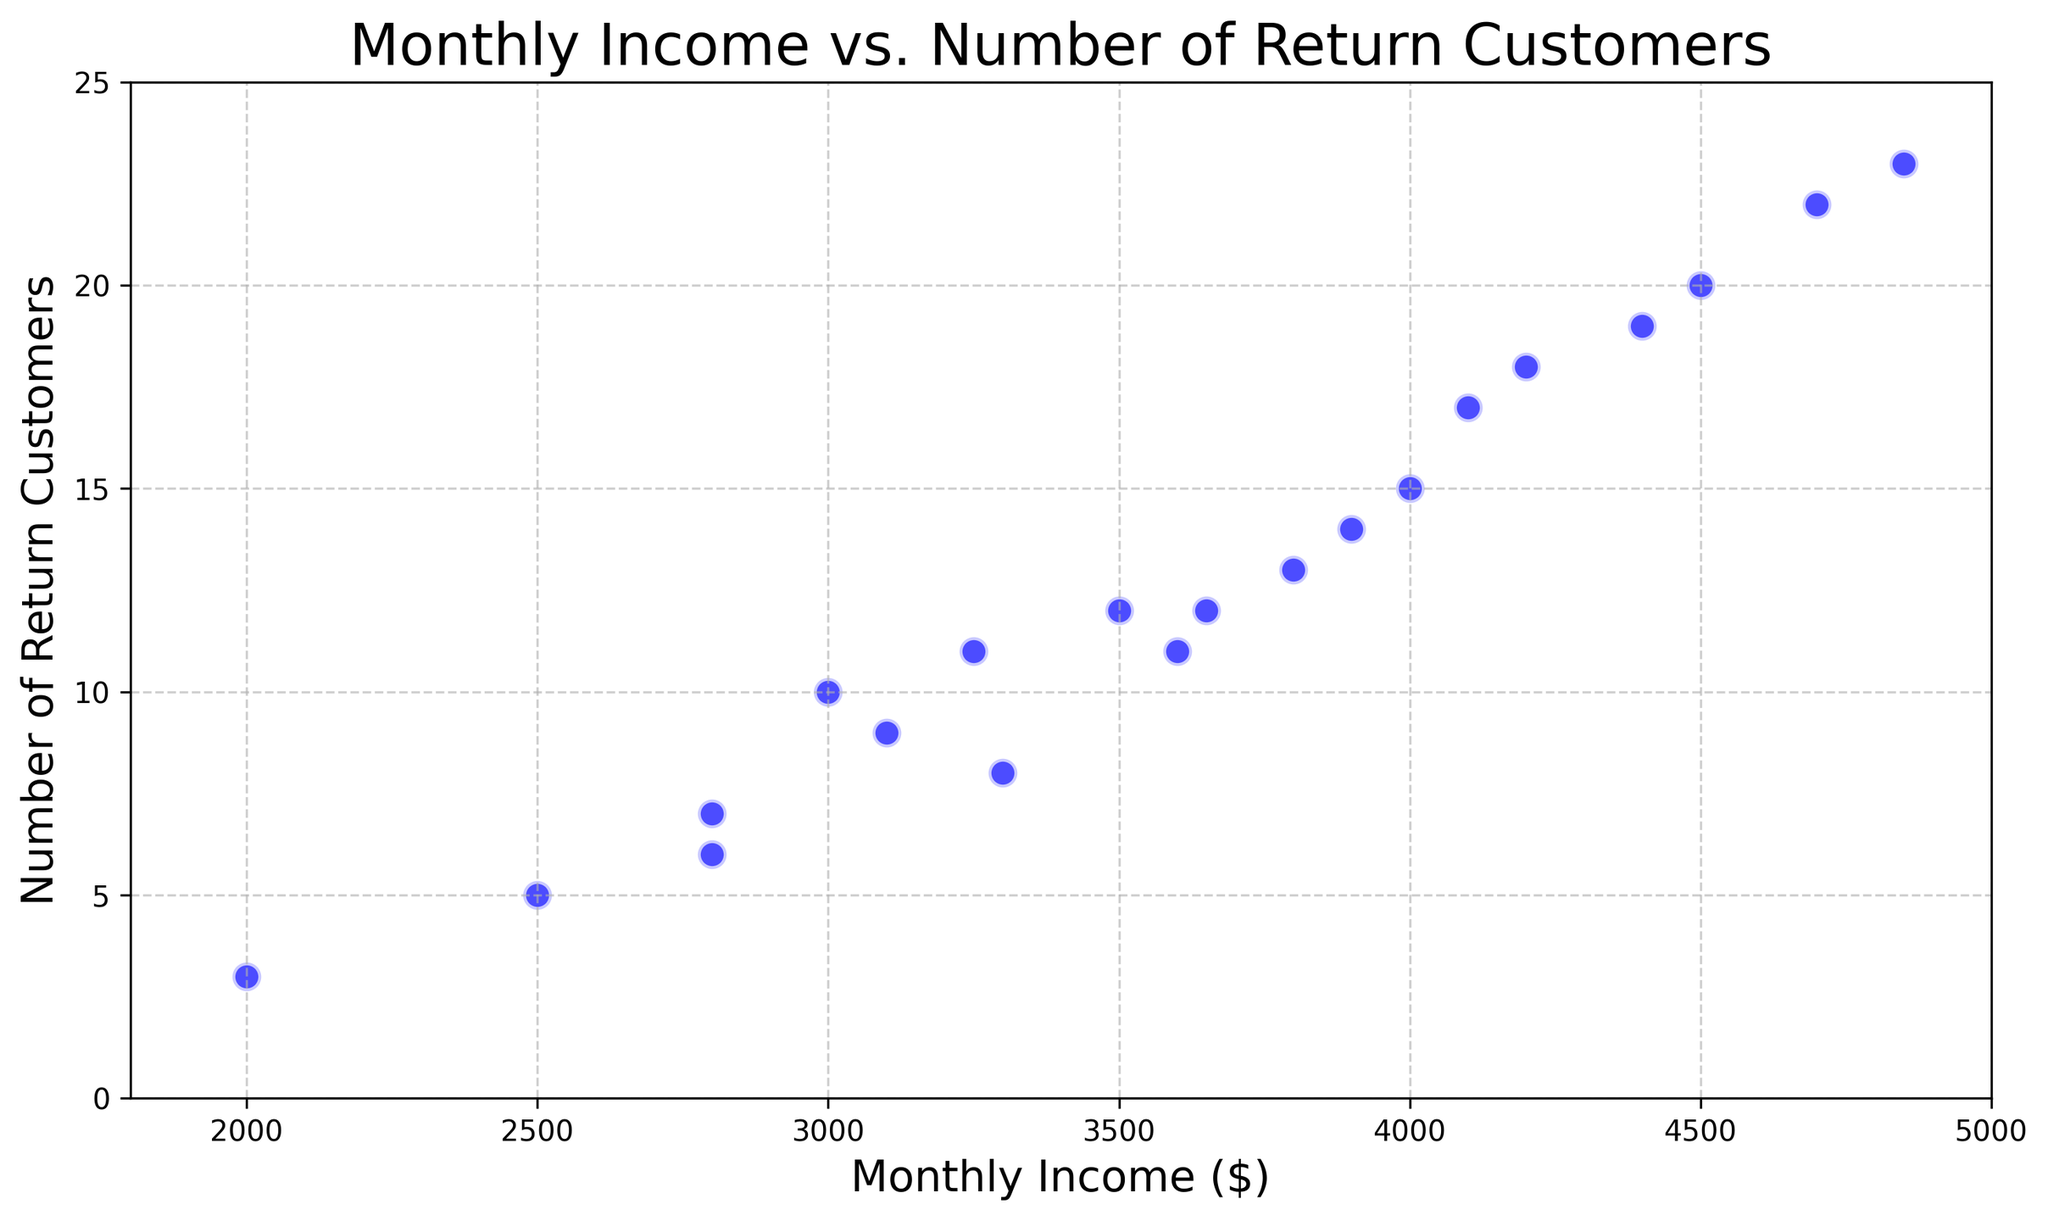What's the relationship between Monthly Income and Number of Return Customers on average? To understand the average relationship, you can look at the general trend in the scatter plot where more return customers tend to be associated with higher monthly income values. This increasing trend indicates a positive relationship between the two variables.
Answer: Positive correlation Which data point has the highest Monthly Income, and how many Return Customers does it correspond to? The highest Monthly Income is $4850, and visually, it corresponds to the data point at the top right corner of the scatter plot with 23 Return Customers.
Answer: 23 How does the Monthly Income for 20 Return Customers compare to that for 12 Return Customers? For 20 Return Customers, the Monthly Income is $4500 and for 12 Return Customers, there are two data points at $3500 and $3650. Hence, the Monthly Income is higher for 20 Return Customers compared to 12 Return Customers
Answer: Higher What is the range of Monthly Income values shown in the scatter plot? The lowest Monthly Income in the scatter plot is $2000 and the highest is $4850, so the range is $4850 - $2000.
Answer: $2850 What is the median Monthly Income among all the data points? To find the median Monthly Income, sort the Monthly Income values: 2000, 2500, 2800, 2800, 3000, 3100, 3250, 3300, 3500, 3600, 3650, 3800, 3900, 4000, 4100, 4200, 4400, 4500, 4700, 4850. The median value (the middle value) is the average of the 10th and 11th values: (3500 + 3600)/2 = 3550.
Answer: $3550 How many customers return when the Monthly Income is $3100? By directly referencing the scatter plot, you can see that $3100 Monthly Income corresponds to 9 Return Customers.
Answer: 9 Are there any outliers in terms of the Number of Return Customers? Analyzing the scatter plot, the point with 23 Return Customers and $4850 Monthly Income could be considered an outlier as it is distinctly higher than other points.
Answer: Yes For a Monthly Income of $4000, how many Return Customers are there? Looking at the scatter plot, $4000 Monthly Income corresponds to 15 Return Customers.
Answer: 15 What is the average Monthly Income for Return Customers between 10 and 15 inclusive? First, identify the points where Return Customers are 10, 11, 12, 13, 14, or 15. These correspond to Monthly Incomes of $3000, $3250, $3500, $3650, $3800, and $3900. Their average Monthly Income is (3000 + 3250 + 3500 + 3650 + 3800 + 3900)/6 = $3516.67.
Answer: $3516.67 How many data points indicate less than 10 Return Customers? Counting the data points from the scatter plot with Return Customers less than 10, there are 6 such points.
Answer: 6 